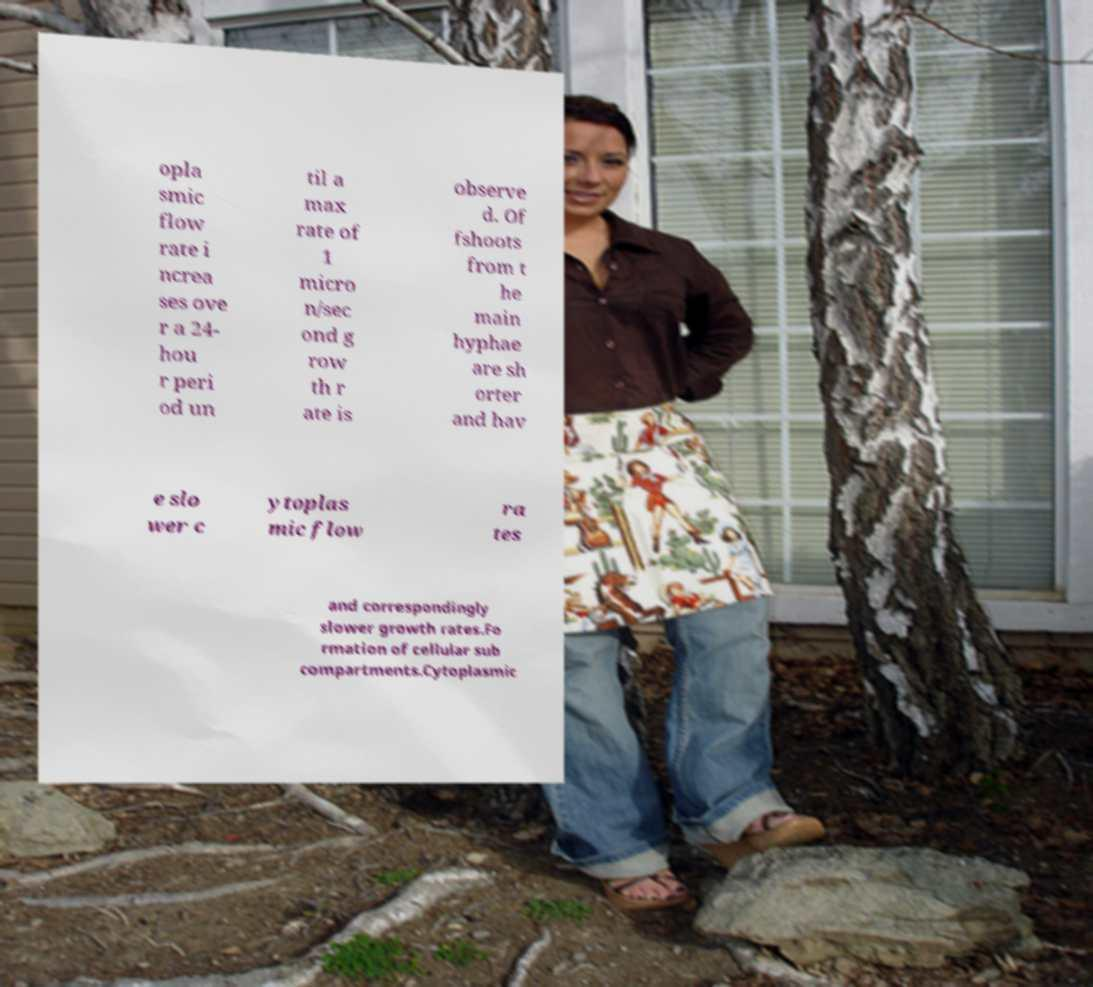For documentation purposes, I need the text within this image transcribed. Could you provide that? opla smic flow rate i ncrea ses ove r a 24- hou r peri od un til a max rate of 1 micro n/sec ond g row th r ate is observe d. Of fshoots from t he main hyphae are sh orter and hav e slo wer c ytoplas mic flow ra tes and correspondingly slower growth rates.Fo rmation of cellular sub compartments.Cytoplasmic 